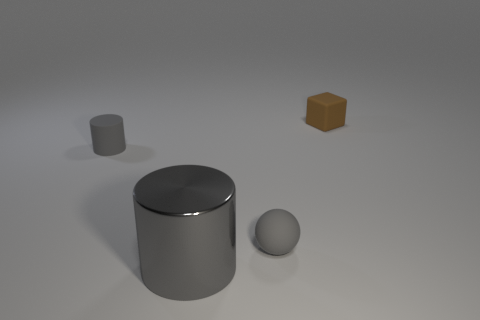Add 1 tiny brown things. How many objects exist? 5 Subtract all blocks. How many objects are left? 3 Subtract all cyan metal cubes. Subtract all small gray objects. How many objects are left? 2 Add 3 brown objects. How many brown objects are left? 4 Add 3 green matte cylinders. How many green matte cylinders exist? 3 Subtract 0 yellow cylinders. How many objects are left? 4 